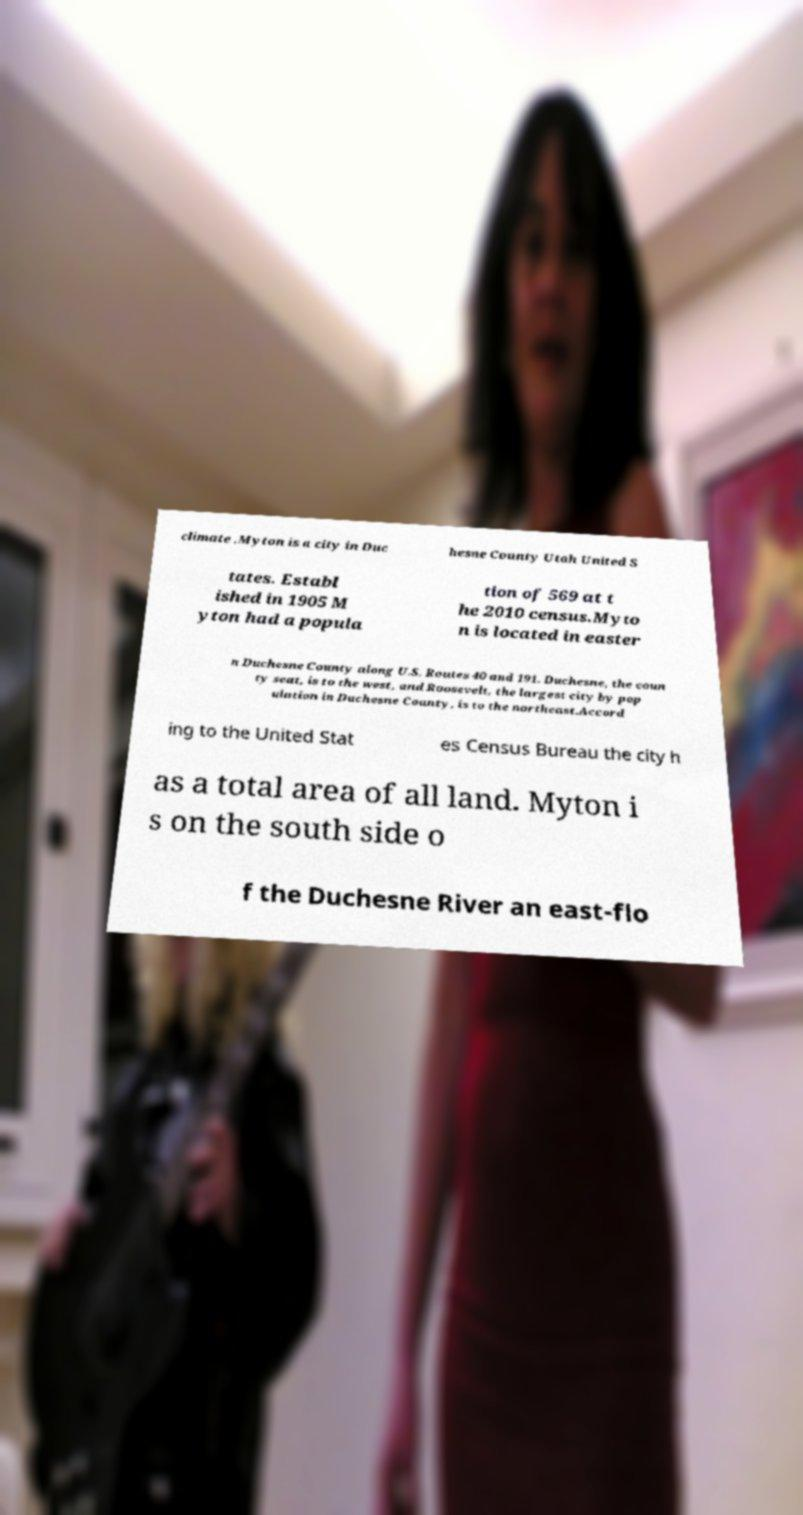Please identify and transcribe the text found in this image. climate .Myton is a city in Duc hesne County Utah United S tates. Establ ished in 1905 M yton had a popula tion of 569 at t he 2010 census.Myto n is located in easter n Duchesne County along U.S. Routes 40 and 191. Duchesne, the coun ty seat, is to the west, and Roosevelt, the largest city by pop ulation in Duchesne County, is to the northeast.Accord ing to the United Stat es Census Bureau the city h as a total area of all land. Myton i s on the south side o f the Duchesne River an east-flo 